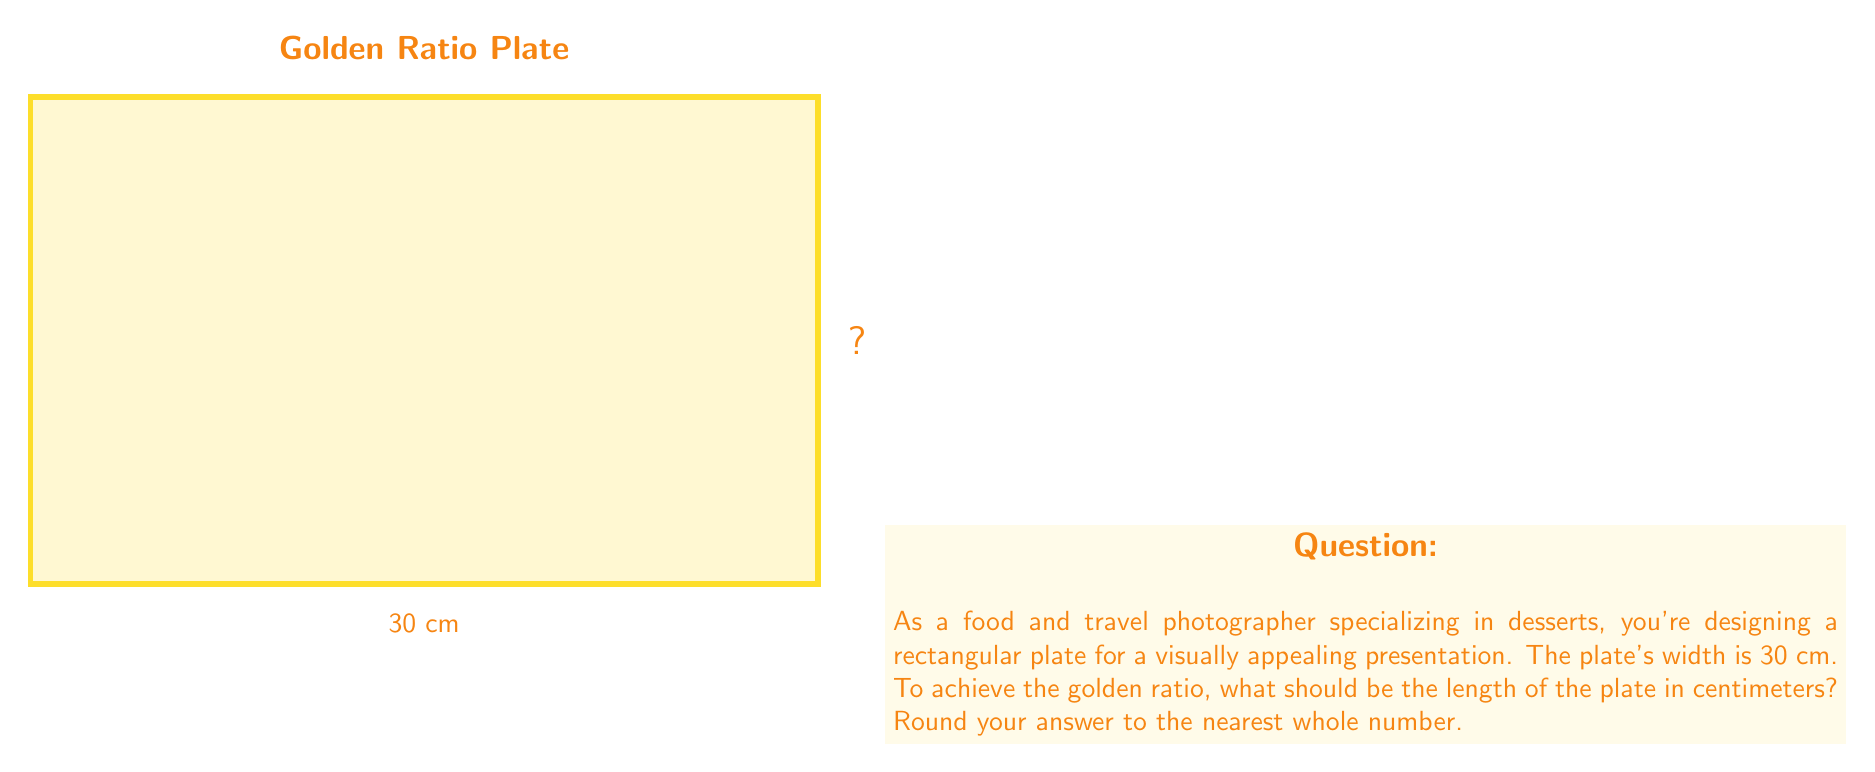Can you answer this question? To solve this problem, we need to use the golden ratio formula and apply it to the dimensions of the plate. Let's break it down step-by-step:

1) The golden ratio, denoted by φ (phi), is approximately equal to 1.618033988749895.

2) For a rectangle to have the golden ratio, the ratio of the longer side to the shorter side should be equal to φ.

3) Let's denote the length of the plate as L. We know the width is 30 cm.

4) We can set up the equation:

   $$\frac{L}{30} = φ$$

5) Solving for L:

   $$L = 30 * φ$$

6) Substituting the value of φ:

   $$L = 30 * 1.618033988749895$$

7) Calculating:

   $$L = 48.54101966249685 \text{ cm}$$

8) Rounding to the nearest whole number:

   $$L ≈ 49 \text{ cm}$$

Therefore, to achieve the golden ratio, the length of the plate should be 49 cm.
Answer: 49 cm 